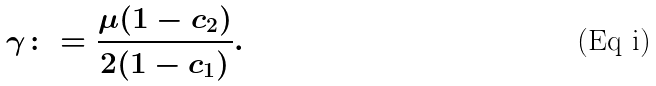<formula> <loc_0><loc_0><loc_500><loc_500>\gamma \colon = \frac { \mu ( 1 - c _ { 2 } ) } { 2 ( 1 - c _ { 1 } ) } .</formula> 